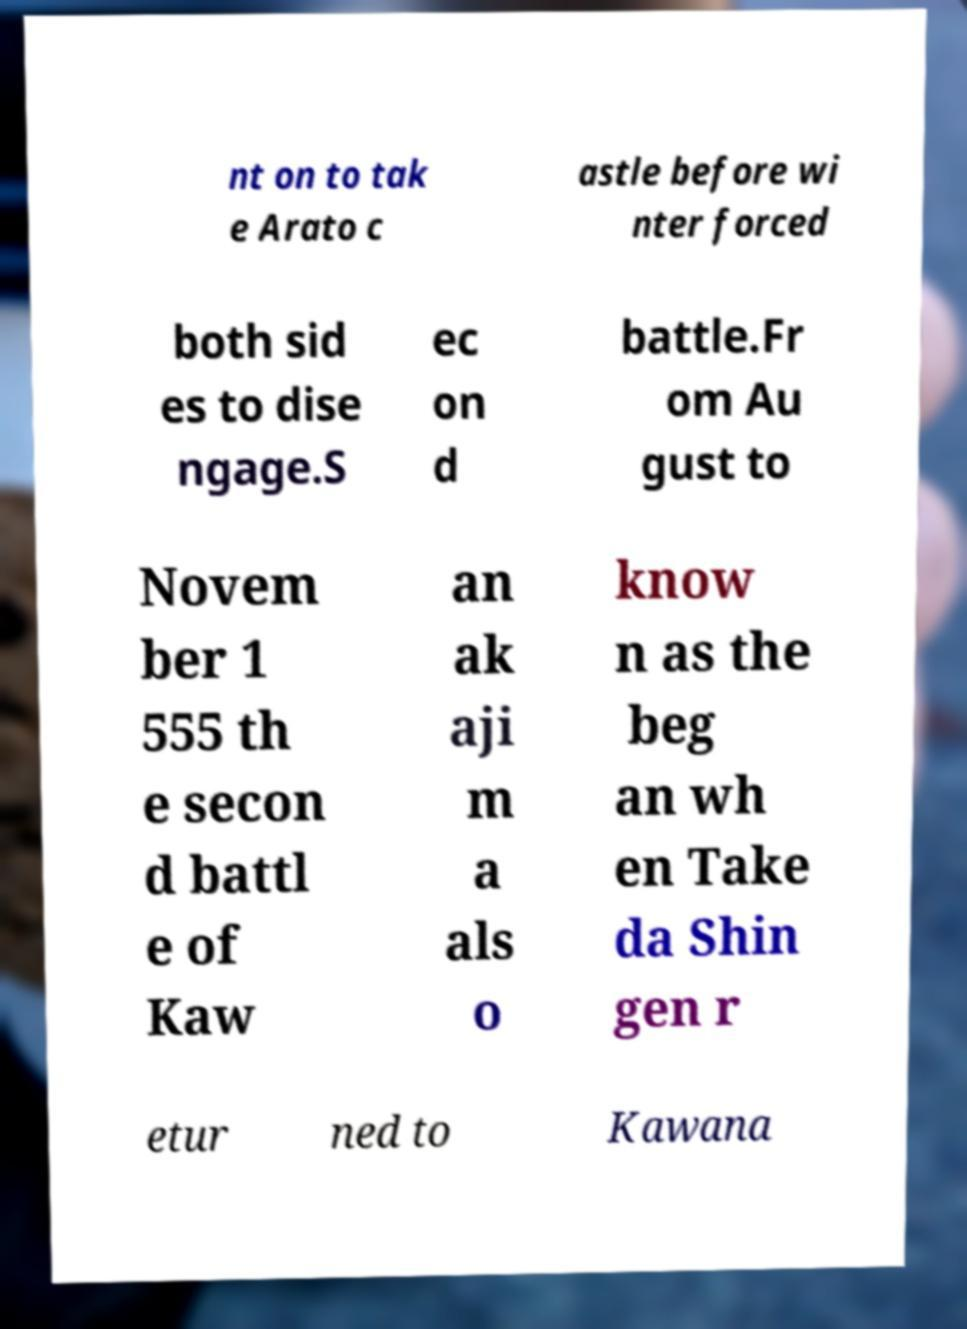There's text embedded in this image that I need extracted. Can you transcribe it verbatim? nt on to tak e Arato c astle before wi nter forced both sid es to dise ngage.S ec on d battle.Fr om Au gust to Novem ber 1 555 th e secon d battl e of Kaw an ak aji m a als o know n as the beg an wh en Take da Shin gen r etur ned to Kawana 